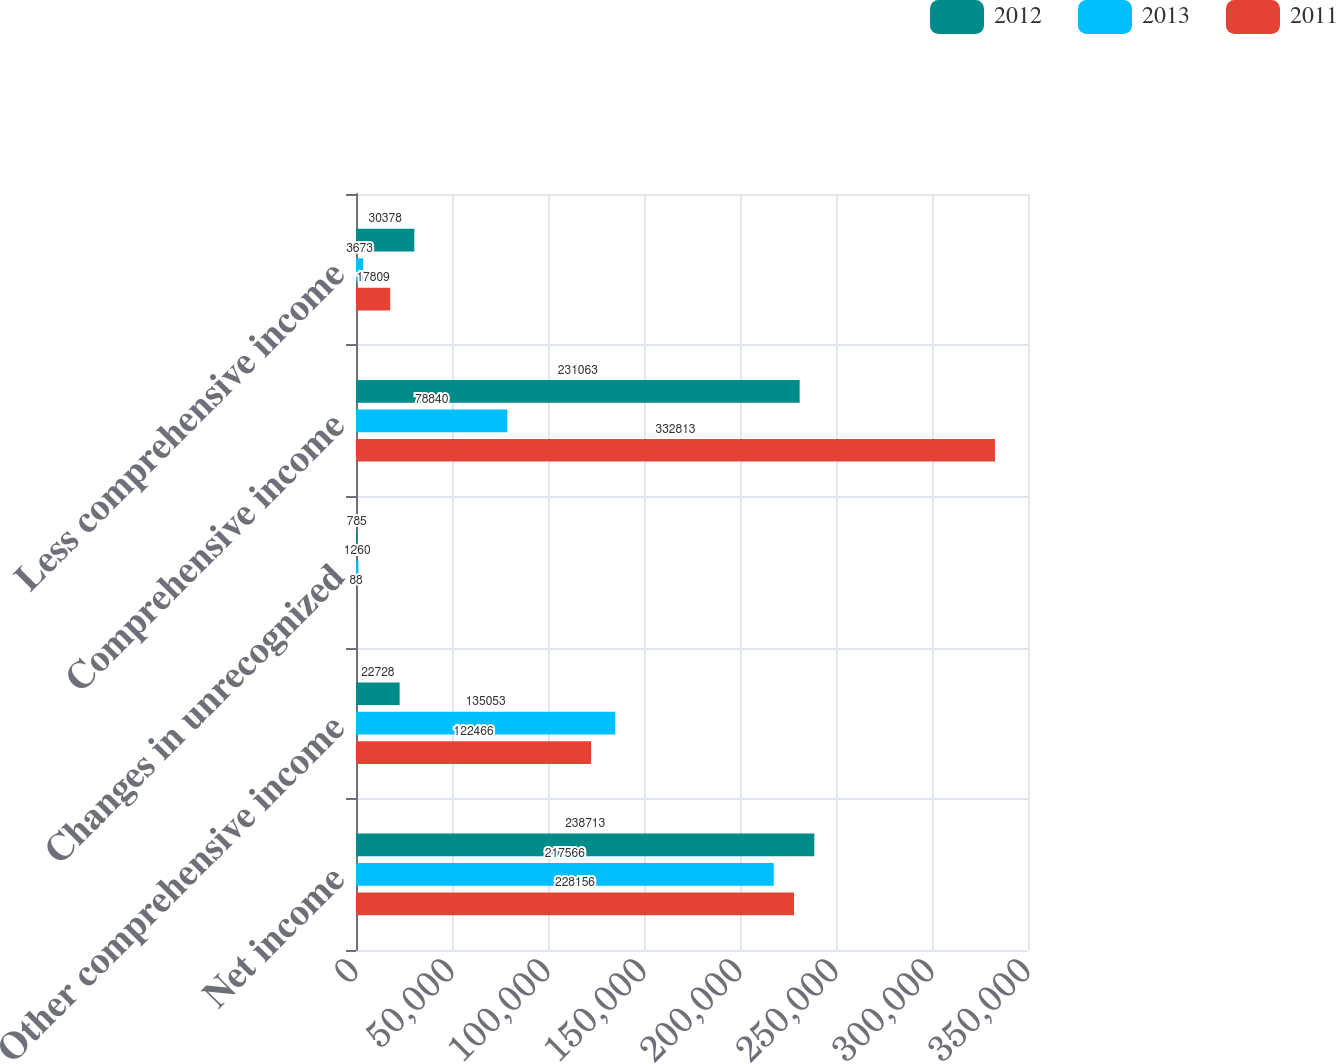Convert chart. <chart><loc_0><loc_0><loc_500><loc_500><stacked_bar_chart><ecel><fcel>Net income<fcel>Other comprehensive income<fcel>Changes in unrecognized<fcel>Comprehensive income<fcel>Less comprehensive income<nl><fcel>2012<fcel>238713<fcel>22728<fcel>785<fcel>231063<fcel>30378<nl><fcel>2013<fcel>217566<fcel>135053<fcel>1260<fcel>78840<fcel>3673<nl><fcel>2011<fcel>228156<fcel>122466<fcel>88<fcel>332813<fcel>17809<nl></chart> 